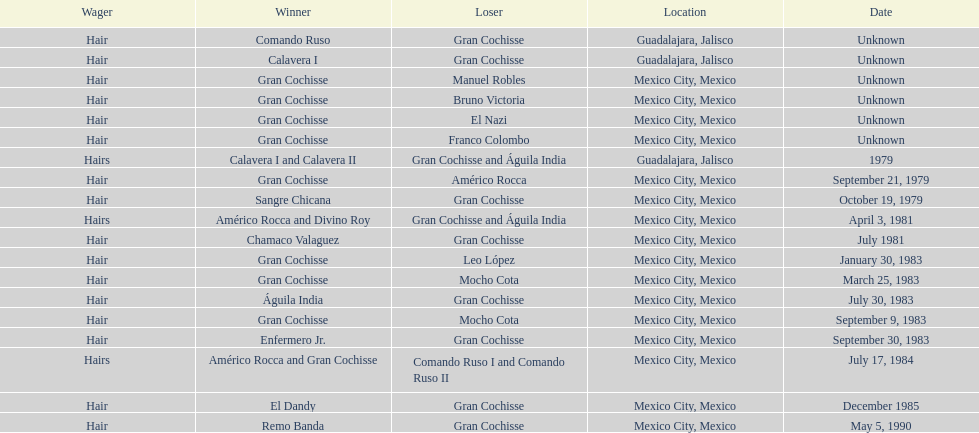When did bruno victoria lose his first game? Unknown. 